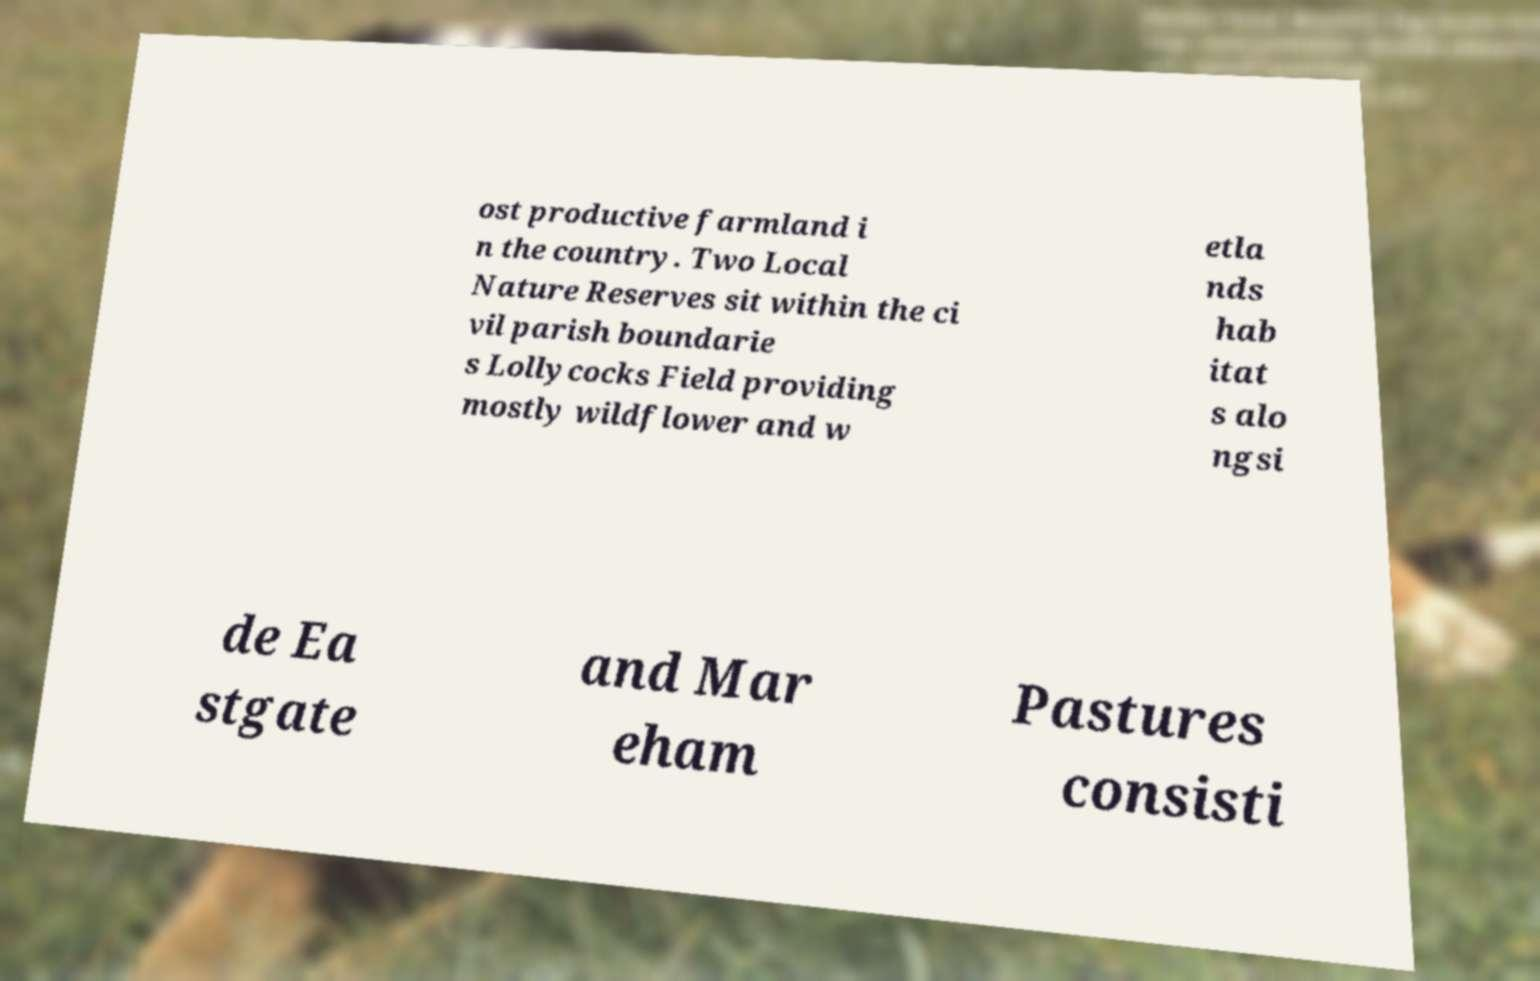For documentation purposes, I need the text within this image transcribed. Could you provide that? ost productive farmland i n the country. Two Local Nature Reserves sit within the ci vil parish boundarie s Lollycocks Field providing mostly wildflower and w etla nds hab itat s alo ngsi de Ea stgate and Mar eham Pastures consisti 